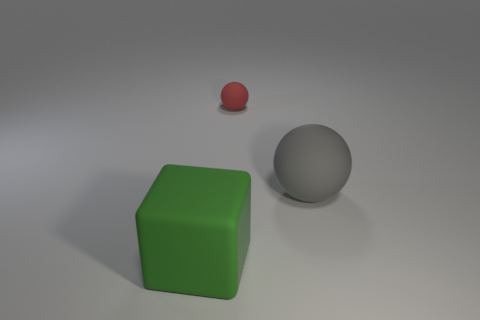Add 3 gray matte things. How many objects exist? 6 Subtract all cubes. How many objects are left? 2 Subtract 0 red cylinders. How many objects are left? 3 Subtract all large green cubes. Subtract all gray spheres. How many objects are left? 1 Add 2 rubber blocks. How many rubber blocks are left? 3 Add 1 red balls. How many red balls exist? 2 